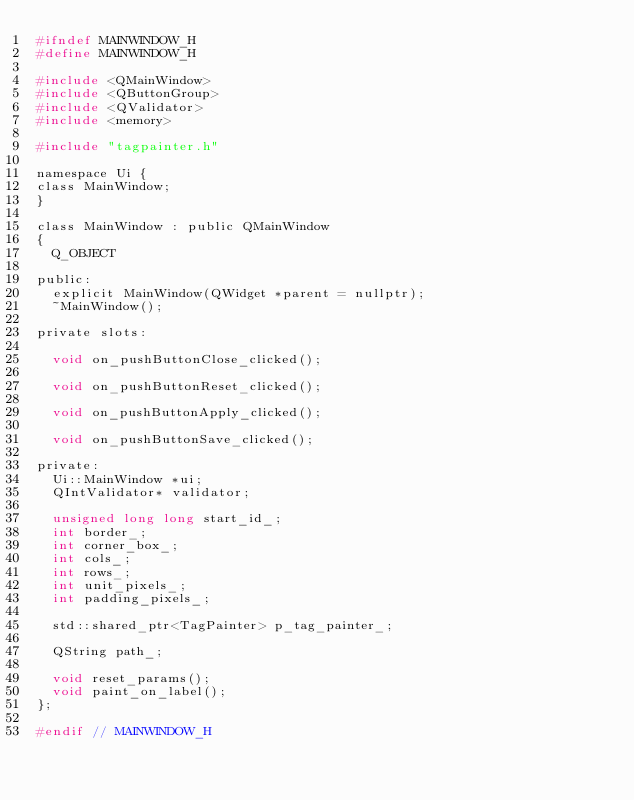<code> <loc_0><loc_0><loc_500><loc_500><_C_>#ifndef MAINWINDOW_H
#define MAINWINDOW_H

#include <QMainWindow>
#include <QButtonGroup>
#include <QValidator>
#include <memory>

#include "tagpainter.h"

namespace Ui {
class MainWindow;
}

class MainWindow : public QMainWindow
{
  Q_OBJECT

public:
  explicit MainWindow(QWidget *parent = nullptr);
  ~MainWindow();

private slots:

  void on_pushButtonClose_clicked();

  void on_pushButtonReset_clicked();

  void on_pushButtonApply_clicked();

  void on_pushButtonSave_clicked();

private:
  Ui::MainWindow *ui;
  QIntValidator* validator;

  unsigned long long start_id_;
  int border_;
  int corner_box_;
  int cols_;
  int rows_;
  int unit_pixels_;
  int padding_pixels_;

  std::shared_ptr<TagPainter> p_tag_painter_;

  QString path_;

  void reset_params();
  void paint_on_label();
};

#endif // MAINWINDOW_H
</code> 